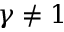Convert formula to latex. <formula><loc_0><loc_0><loc_500><loc_500>\gamma \neq 1</formula> 